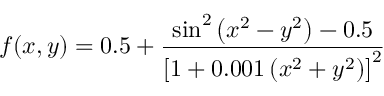<formula> <loc_0><loc_0><loc_500><loc_500>f ( x , y ) = 0 . 5 + { \frac { \sin ^ { 2 } \left ( x ^ { 2 } - y ^ { 2 } \right ) - 0 . 5 } { \left [ 1 + 0 . 0 0 1 \left ( x ^ { 2 } + y ^ { 2 } \right ) \right ] ^ { 2 } } }</formula> 